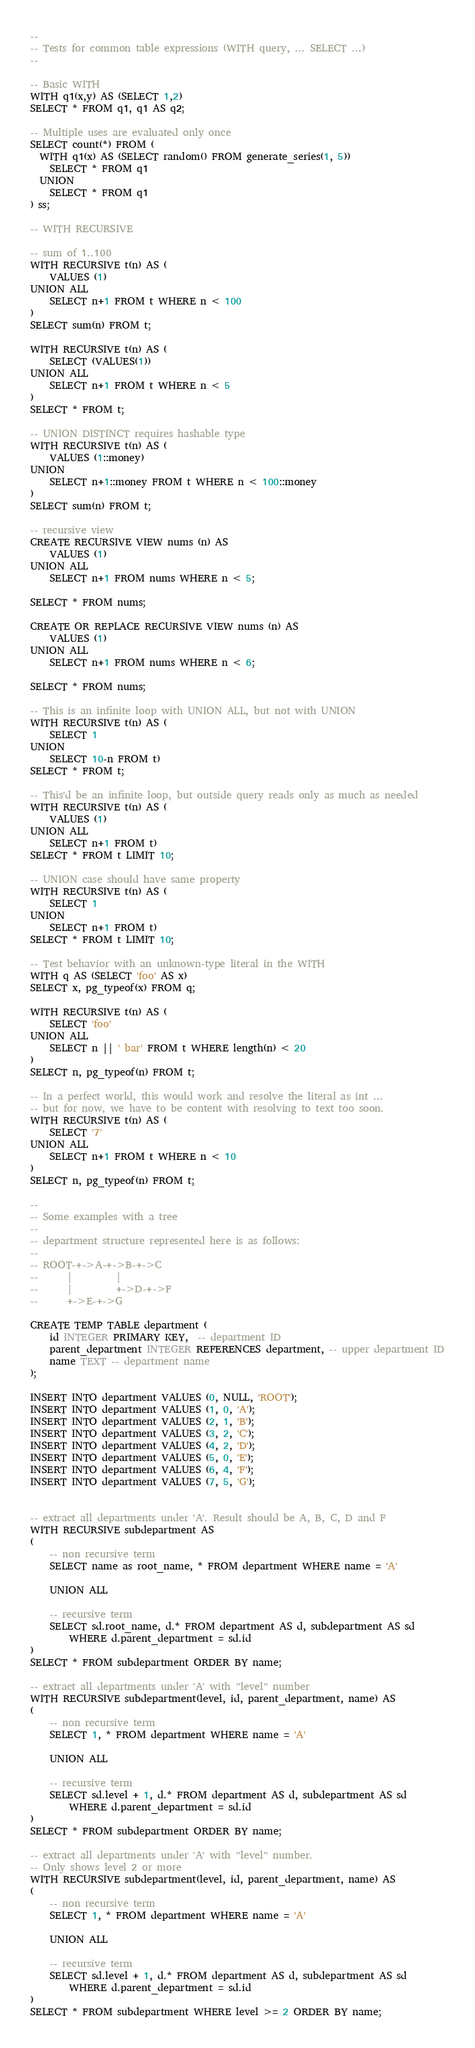<code> <loc_0><loc_0><loc_500><loc_500><_SQL_>--
-- Tests for common table expressions (WITH query, ... SELECT ...)
--

-- Basic WITH
WITH q1(x,y) AS (SELECT 1,2)
SELECT * FROM q1, q1 AS q2;

-- Multiple uses are evaluated only once
SELECT count(*) FROM (
  WITH q1(x) AS (SELECT random() FROM generate_series(1, 5))
    SELECT * FROM q1
  UNION
    SELECT * FROM q1
) ss;

-- WITH RECURSIVE

-- sum of 1..100
WITH RECURSIVE t(n) AS (
    VALUES (1)
UNION ALL
    SELECT n+1 FROM t WHERE n < 100
)
SELECT sum(n) FROM t;

WITH RECURSIVE t(n) AS (
    SELECT (VALUES(1))
UNION ALL
    SELECT n+1 FROM t WHERE n < 5
)
SELECT * FROM t;

-- UNION DISTINCT requires hashable type
WITH RECURSIVE t(n) AS (
    VALUES (1::money)
UNION
    SELECT n+1::money FROM t WHERE n < 100::money
)
SELECT sum(n) FROM t;

-- recursive view
CREATE RECURSIVE VIEW nums (n) AS
    VALUES (1)
UNION ALL
    SELECT n+1 FROM nums WHERE n < 5;

SELECT * FROM nums;

CREATE OR REPLACE RECURSIVE VIEW nums (n) AS
    VALUES (1)
UNION ALL
    SELECT n+1 FROM nums WHERE n < 6;

SELECT * FROM nums;

-- This is an infinite loop with UNION ALL, but not with UNION
WITH RECURSIVE t(n) AS (
    SELECT 1
UNION
    SELECT 10-n FROM t)
SELECT * FROM t;

-- This'd be an infinite loop, but outside query reads only as much as needed
WITH RECURSIVE t(n) AS (
    VALUES (1)
UNION ALL
    SELECT n+1 FROM t)
SELECT * FROM t LIMIT 10;

-- UNION case should have same property
WITH RECURSIVE t(n) AS (
    SELECT 1
UNION
    SELECT n+1 FROM t)
SELECT * FROM t LIMIT 10;

-- Test behavior with an unknown-type literal in the WITH
WITH q AS (SELECT 'foo' AS x)
SELECT x, pg_typeof(x) FROM q;

WITH RECURSIVE t(n) AS (
    SELECT 'foo'
UNION ALL
    SELECT n || ' bar' FROM t WHERE length(n) < 20
)
SELECT n, pg_typeof(n) FROM t;

-- In a perfect world, this would work and resolve the literal as int ...
-- but for now, we have to be content with resolving to text too soon.
WITH RECURSIVE t(n) AS (
    SELECT '7'
UNION ALL
    SELECT n+1 FROM t WHERE n < 10
)
SELECT n, pg_typeof(n) FROM t;

--
-- Some examples with a tree
--
-- department structure represented here is as follows:
--
-- ROOT-+->A-+->B-+->C
--      |         |
--      |         +->D-+->F
--      +->E-+->G

CREATE TEMP TABLE department (
	id INTEGER PRIMARY KEY,  -- department ID
	parent_department INTEGER REFERENCES department, -- upper department ID
	name TEXT -- department name
);

INSERT INTO department VALUES (0, NULL, 'ROOT');
INSERT INTO department VALUES (1, 0, 'A');
INSERT INTO department VALUES (2, 1, 'B');
INSERT INTO department VALUES (3, 2, 'C');
INSERT INTO department VALUES (4, 2, 'D');
INSERT INTO department VALUES (5, 0, 'E');
INSERT INTO department VALUES (6, 4, 'F');
INSERT INTO department VALUES (7, 5, 'G');


-- extract all departments under 'A'. Result should be A, B, C, D and F
WITH RECURSIVE subdepartment AS
(
	-- non recursive term
	SELECT name as root_name, * FROM department WHERE name = 'A'

	UNION ALL

	-- recursive term
	SELECT sd.root_name, d.* FROM department AS d, subdepartment AS sd
		WHERE d.parent_department = sd.id
)
SELECT * FROM subdepartment ORDER BY name;

-- extract all departments under 'A' with "level" number
WITH RECURSIVE subdepartment(level, id, parent_department, name) AS
(
	-- non recursive term
	SELECT 1, * FROM department WHERE name = 'A'

	UNION ALL

	-- recursive term
	SELECT sd.level + 1, d.* FROM department AS d, subdepartment AS sd
		WHERE d.parent_department = sd.id
)
SELECT * FROM subdepartment ORDER BY name;

-- extract all departments under 'A' with "level" number.
-- Only shows level 2 or more
WITH RECURSIVE subdepartment(level, id, parent_department, name) AS
(
	-- non recursive term
	SELECT 1, * FROM department WHERE name = 'A'

	UNION ALL

	-- recursive term
	SELECT sd.level + 1, d.* FROM department AS d, subdepartment AS sd
		WHERE d.parent_department = sd.id
)
SELECT * FROM subdepartment WHERE level >= 2 ORDER BY name;
</code> 